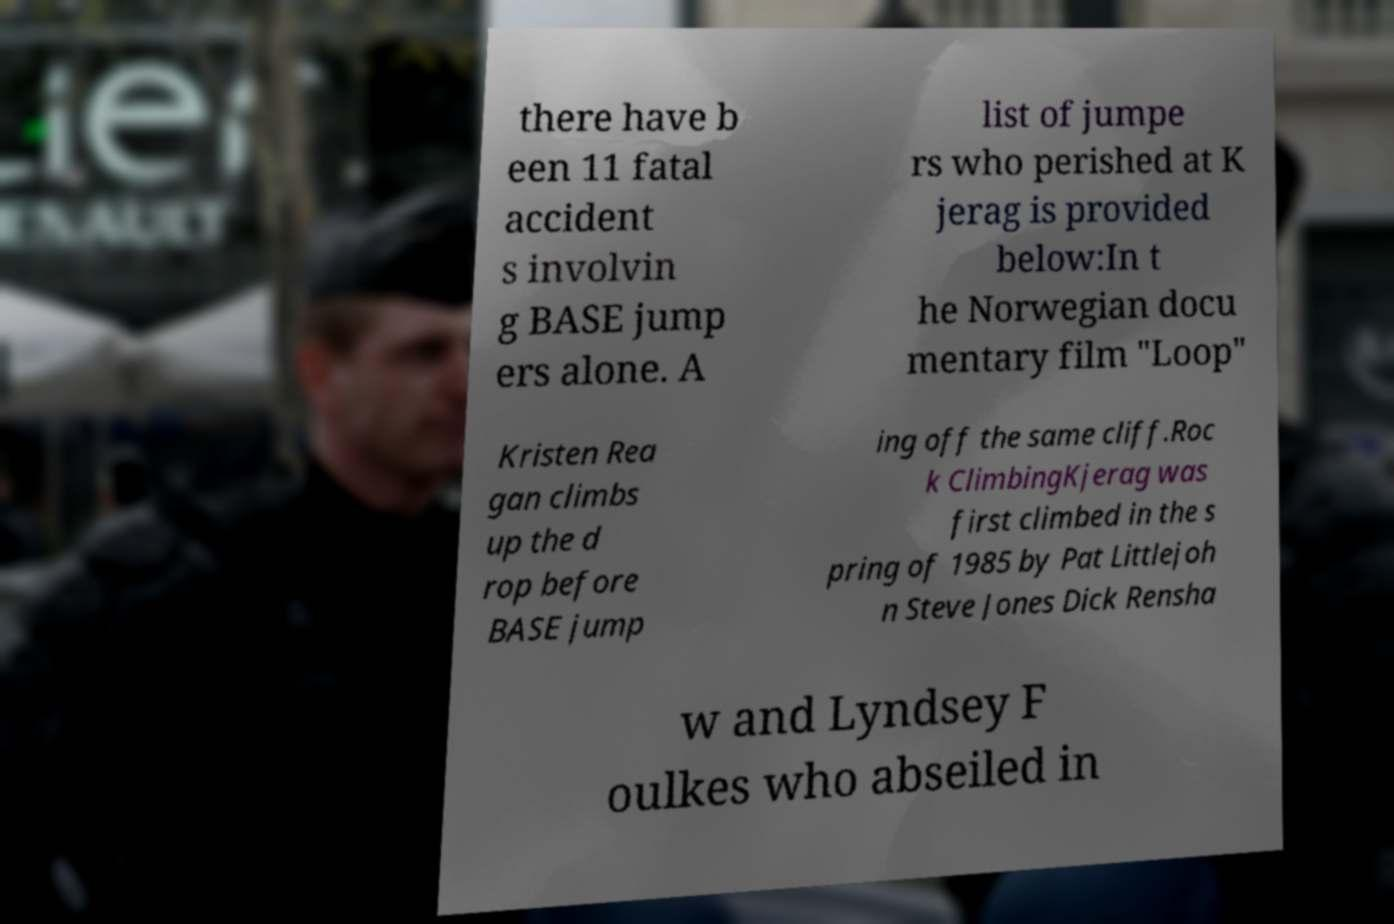Can you read and provide the text displayed in the image?This photo seems to have some interesting text. Can you extract and type it out for me? there have b een 11 fatal accident s involvin g BASE jump ers alone. A list of jumpe rs who perished at K jerag is provided below:In t he Norwegian docu mentary film "Loop" Kristen Rea gan climbs up the d rop before BASE jump ing off the same cliff.Roc k ClimbingKjerag was first climbed in the s pring of 1985 by Pat Littlejoh n Steve Jones Dick Rensha w and Lyndsey F oulkes who abseiled in 